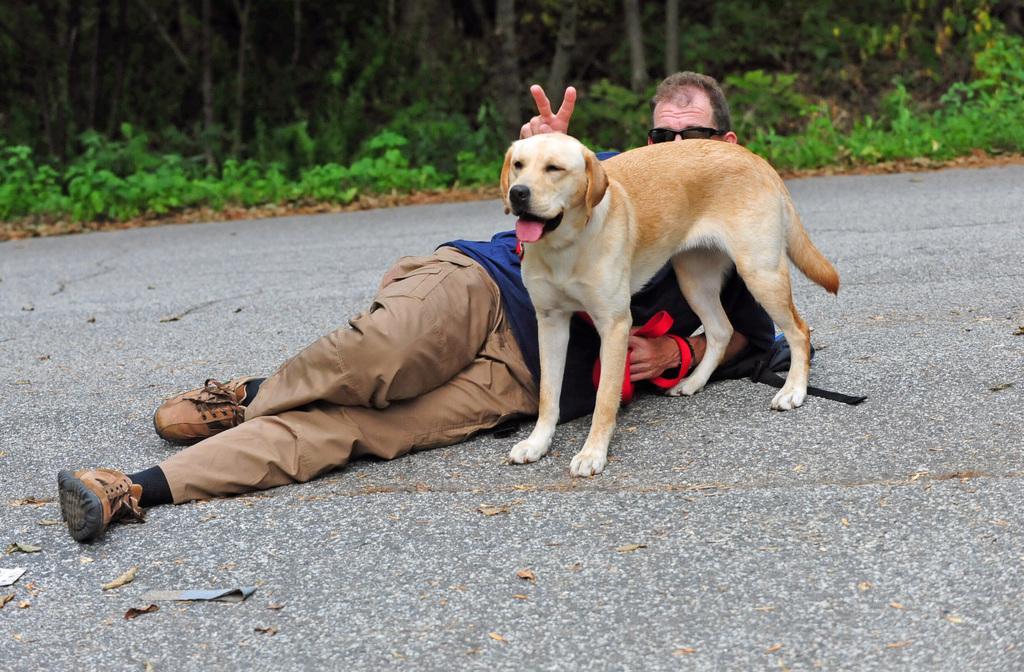Please provide a concise description of this image. There is a man lying on the road,and this is a dog. At background there are trees and plants. This man is wearing T-shirt,trouser,shoes and goggles. 